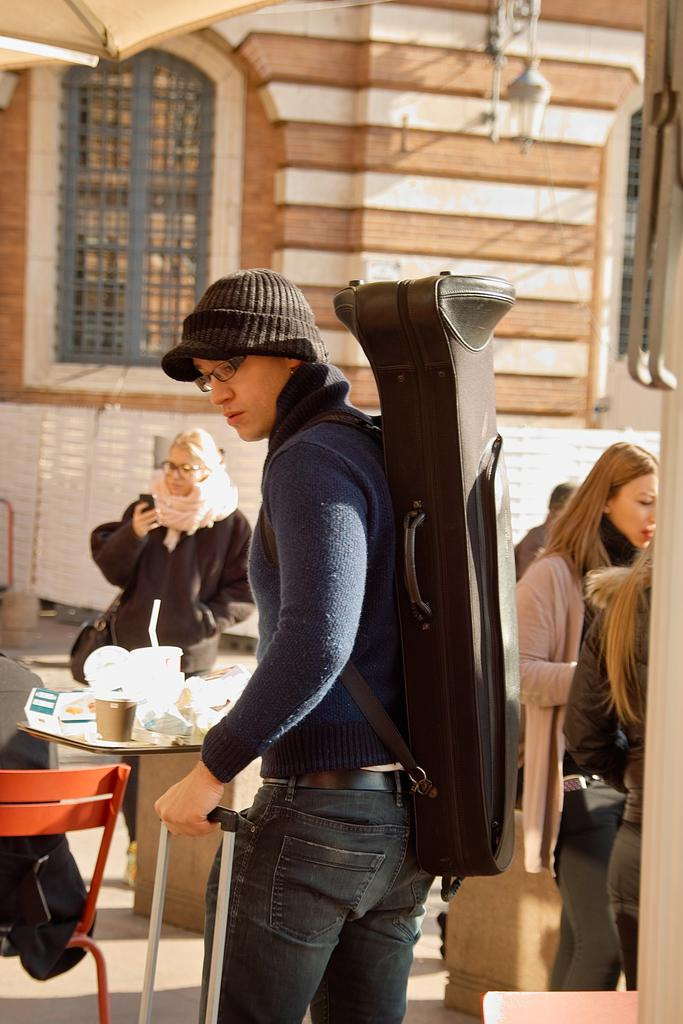What is the person in the image carrying? The person in the image is carrying a backpack. What can be seen on the road in the image? There are women standing on the road in the image. What type of cannon is being fired in the image? There is no cannon present in the image. How many clocks can be seen in the image? There are no clocks visible in the image. 